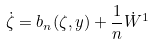Convert formula to latex. <formula><loc_0><loc_0><loc_500><loc_500>\dot { \zeta } = b _ { n } ( \zeta , y ) + \frac { 1 } { n } \dot { W } ^ { 1 }</formula> 